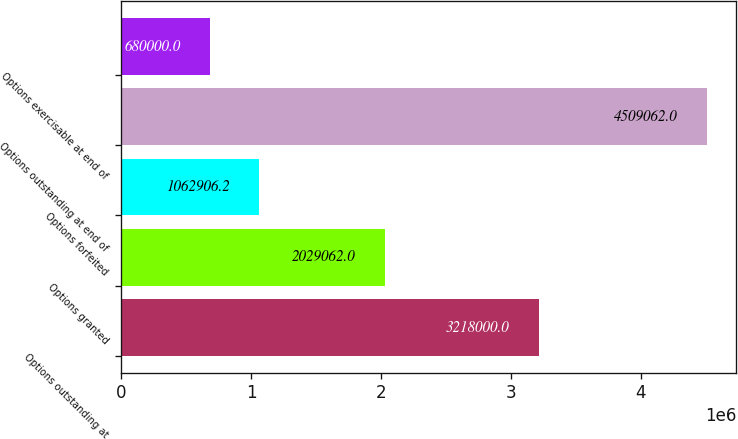Convert chart. <chart><loc_0><loc_0><loc_500><loc_500><bar_chart><fcel>Options outstanding at<fcel>Options granted<fcel>Options forfeited<fcel>Options outstanding at end of<fcel>Options exercisable at end of<nl><fcel>3.218e+06<fcel>2.02906e+06<fcel>1.06291e+06<fcel>4.50906e+06<fcel>680000<nl></chart> 